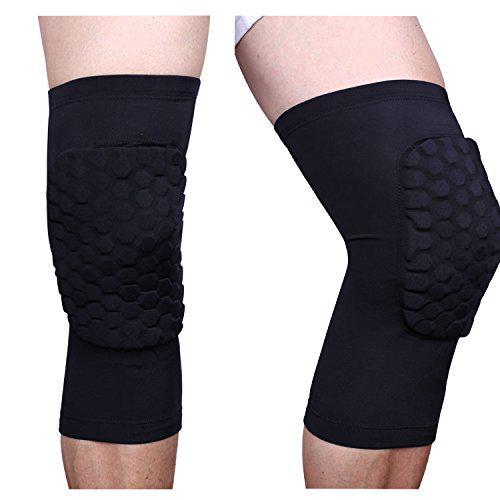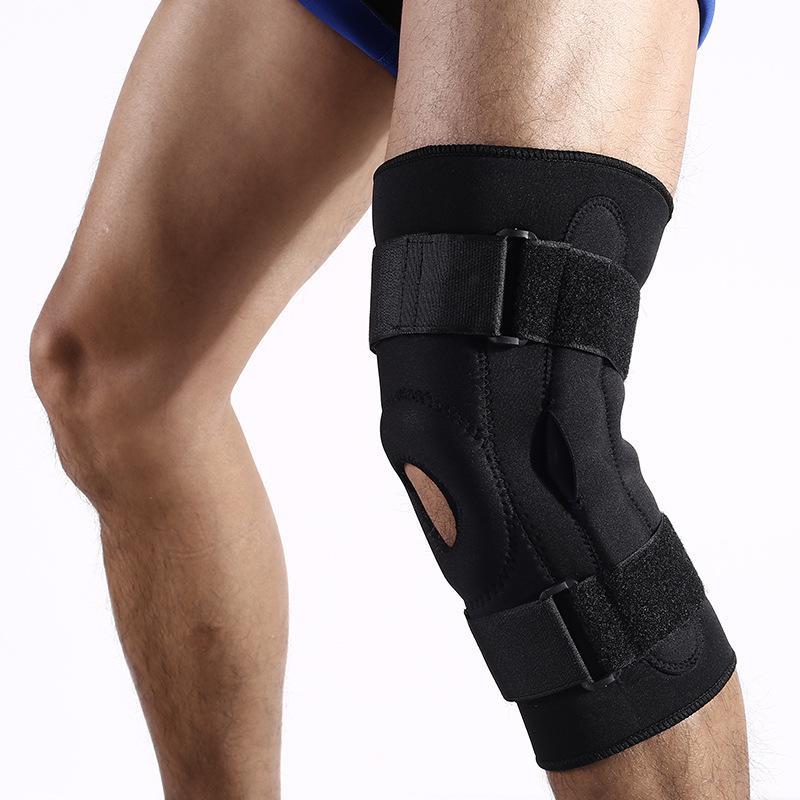The first image is the image on the left, the second image is the image on the right. Given the left and right images, does the statement "All images featuring kneepads include human legs." hold true? Answer yes or no. Yes. 